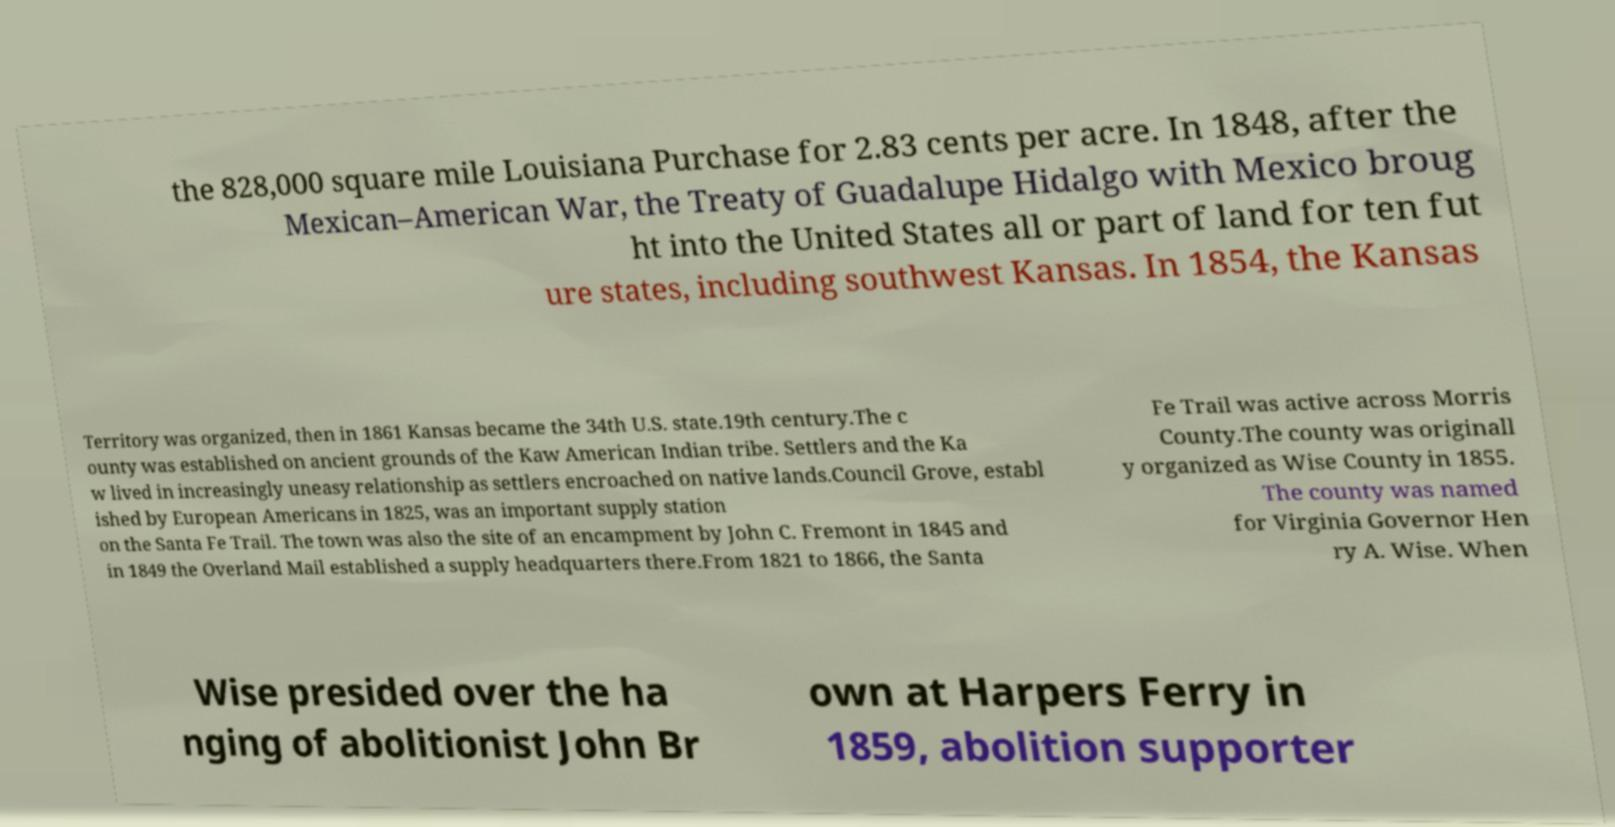There's text embedded in this image that I need extracted. Can you transcribe it verbatim? the 828,000 square mile Louisiana Purchase for 2.83 cents per acre. In 1848, after the Mexican–American War, the Treaty of Guadalupe Hidalgo with Mexico broug ht into the United States all or part of land for ten fut ure states, including southwest Kansas. In 1854, the Kansas Territory was organized, then in 1861 Kansas became the 34th U.S. state.19th century.The c ounty was established on ancient grounds of the Kaw American Indian tribe. Settlers and the Ka w lived in increasingly uneasy relationship as settlers encroached on native lands.Council Grove, establ ished by European Americans in 1825, was an important supply station on the Santa Fe Trail. The town was also the site of an encampment by John C. Fremont in 1845 and in 1849 the Overland Mail established a supply headquarters there.From 1821 to 1866, the Santa Fe Trail was active across Morris County.The county was originall y organized as Wise County in 1855. The county was named for Virginia Governor Hen ry A. Wise. When Wise presided over the ha nging of abolitionist John Br own at Harpers Ferry in 1859, abolition supporter 